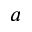<formula> <loc_0><loc_0><loc_500><loc_500>a</formula> 